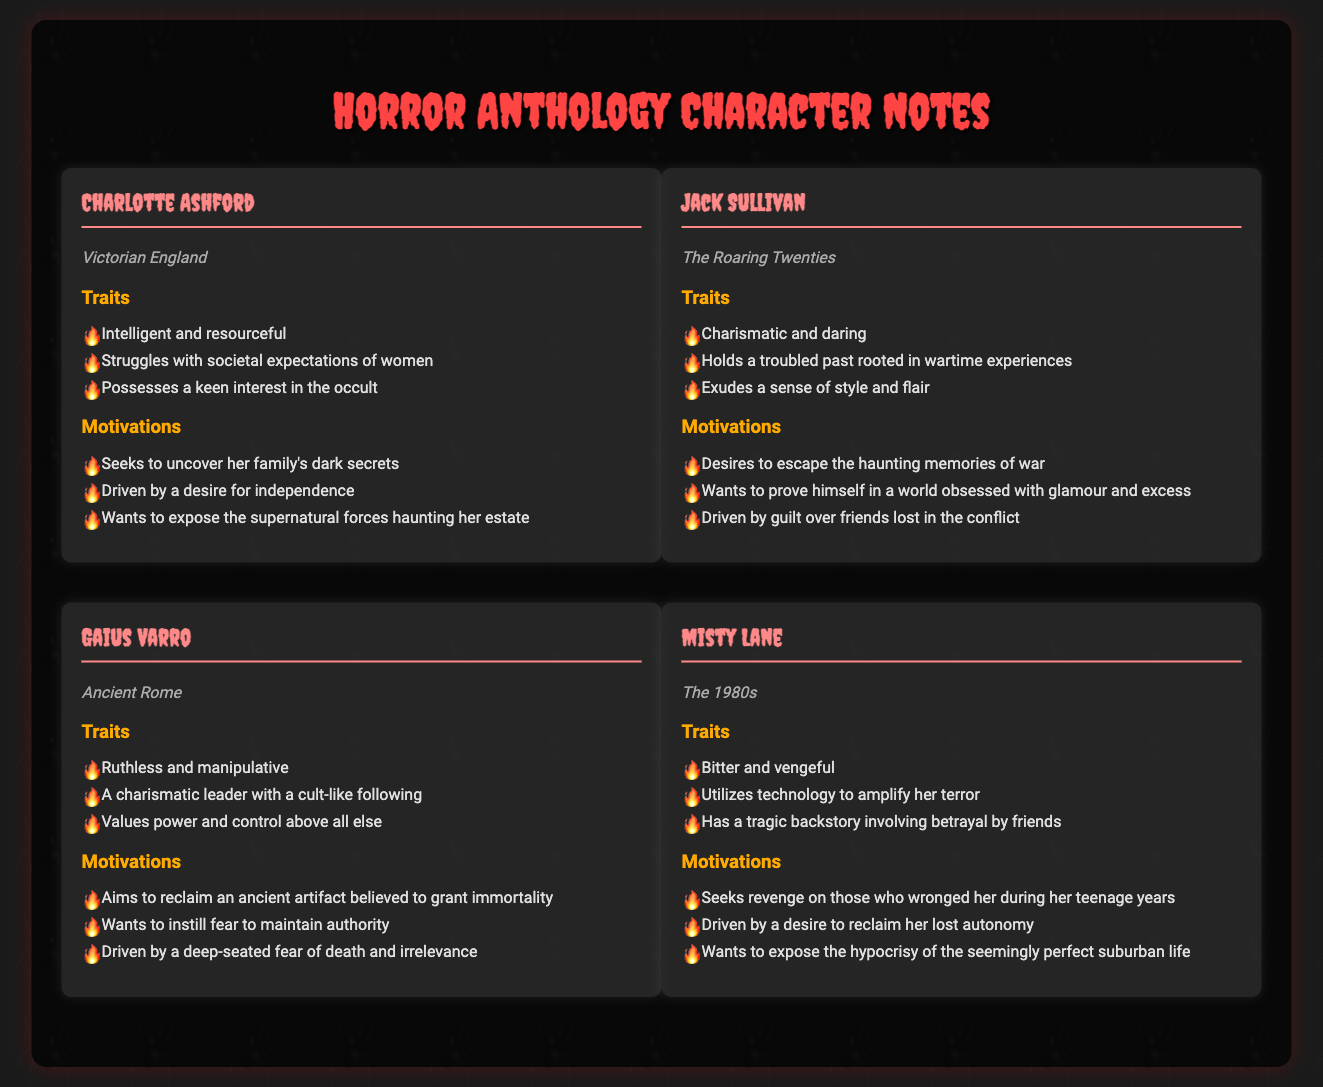what are the traits of Charlotte Ashford? The traits of Charlotte Ashford are listed under the "Traits" section, including being intelligent, resourceful, and struggling with societal expectations.
Answer: Intelligent and resourceful what is Jack Sullivan's primary motivation? Jack Sullivan's primary motivations are detailed in the "Motivations" section, focusing on escaping haunting memories and proving himself.
Answer: Desires to escape the haunting memories of war which era does Gaius Varro belong to? Gaius Varro’s era is indicated in the document, specifically noted in the era section.
Answer: Ancient Rome how does Misty Lane utilize technology? The document specifies Misty Lane’s traits, including utilizing technology to amplify her terror, revealing her approach.
Answer: Utilizes technology to amplify her terror what underlying fear drives Gaius Varro's actions? Gaius Varro's motivations indicate that he is driven by a deep-seated fear of death and irrelevance.
Answer: Fear of death and irrelevance how many characters are listed in the document? The document features four distinct characters, each represented with their traits and motivations.
Answer: Four what is a common theme found in the characters' motivations? The document's characters often share motivations revolving around revenge and uncovering secrets, reflecting personal struggles.
Answer: Revenge and uncovering secrets which character has a tragic backstory involving betrayal? The character associated with a tragic backstory involving betrayal is mentioned in the traits section under Misty Lane.
Answer: Misty Lane what visual style is used for the character headings? The character headings use a distinctive cursive font style named "Creepster" to create a thematic visual effect.
Answer: Creepster 